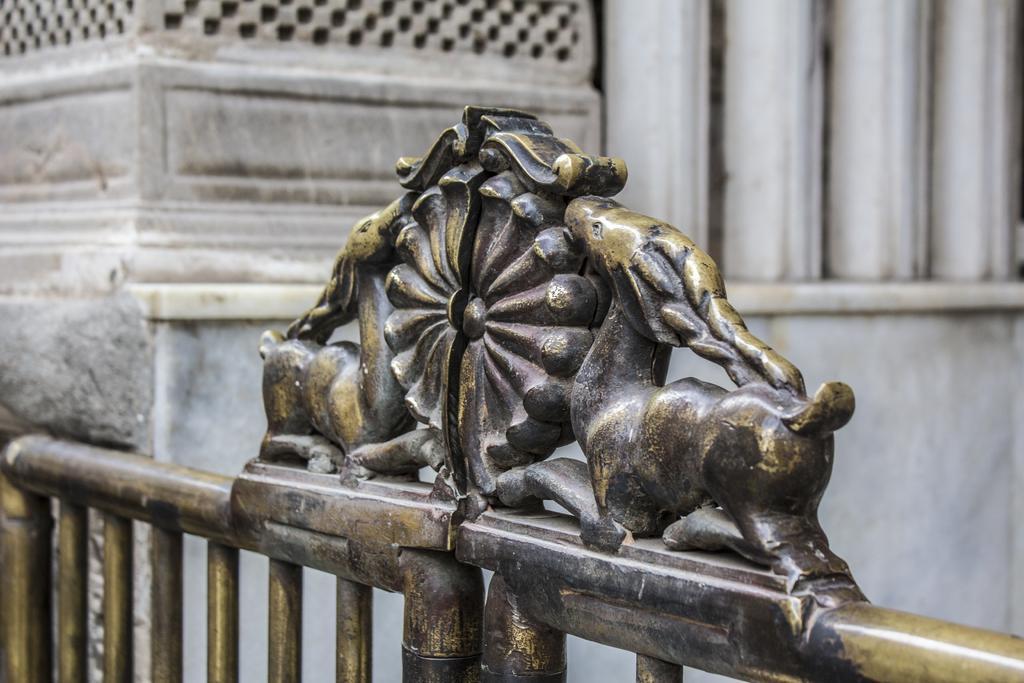Describe this image in one or two sentences. In this image we can see one white color building wall and in front of the wall there is one iron gate. 